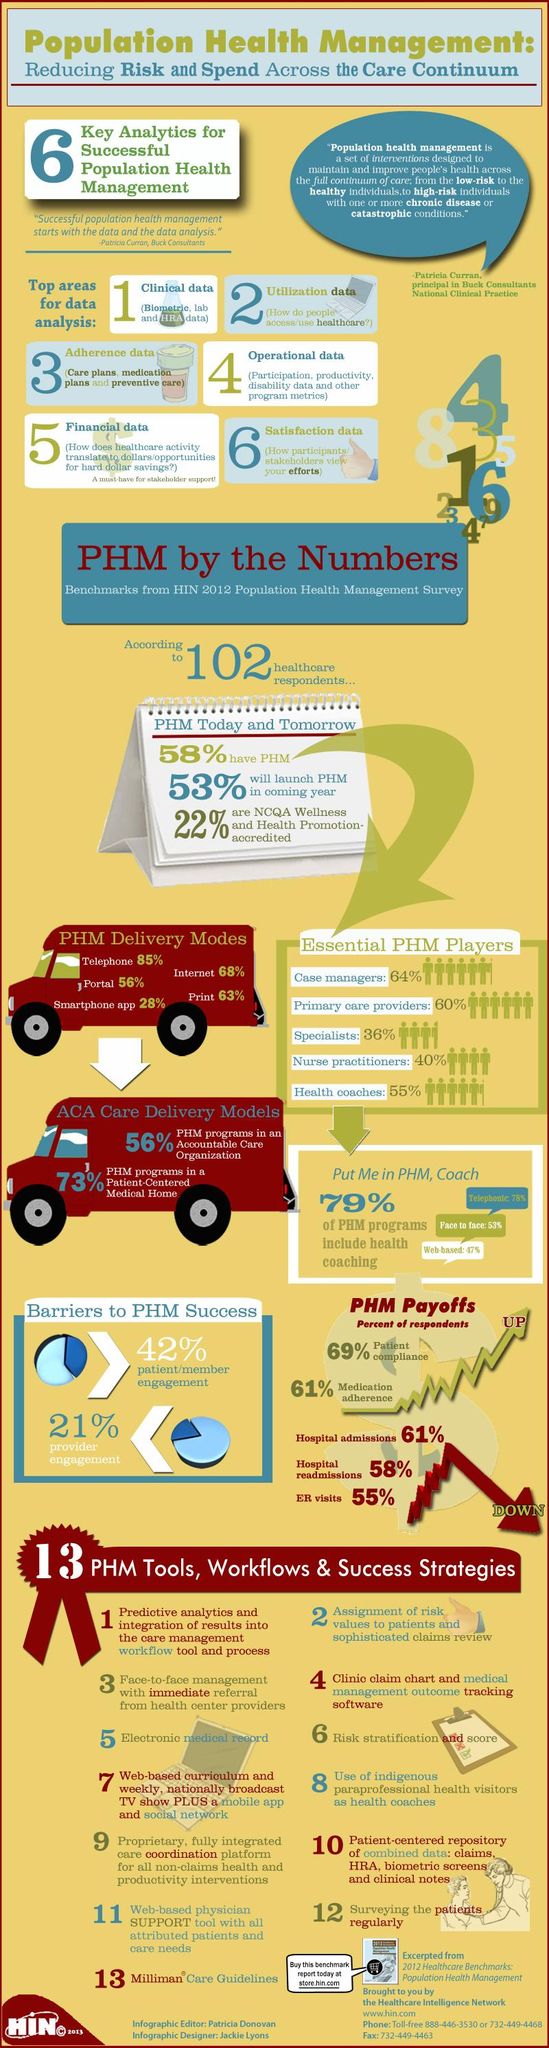Give some essential details in this illustration. Of the group studied, 42% do not have PHM. Of the health promotion programs and services evaluated, 78% have not been accredited by the National Committee for Quality Assurance (NCQA). There are several barriers to the success of personalized health management (PHM), including patient/member engagement and provider engagement. There are approximately 5 essential players in the field of PHM. According to a recent survey, only 27% of PHM programs are not in a patient-centered medical home. 